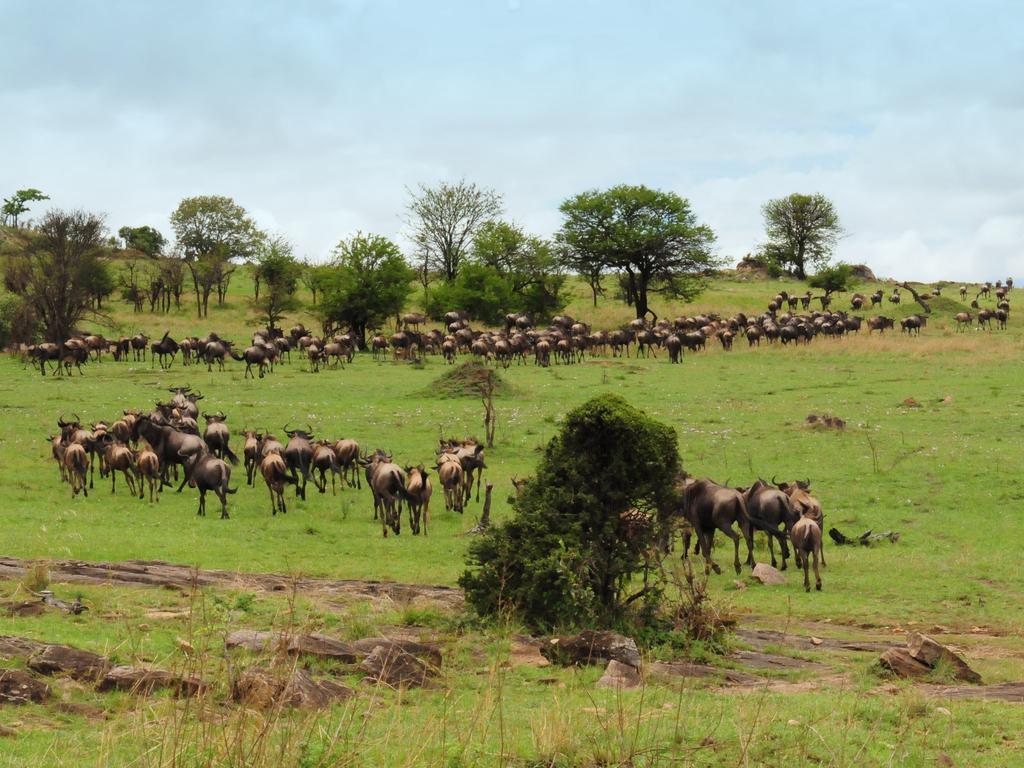Can you describe this image briefly? This image is taken outdoors. At the top of the image there is the sky with clouds. At the bottom of the image there is a ground with grass on it. In the background there are a few trees and plants. In the middle of the image there are a few cattle running on the ground and there are a few rocks. There are a few plants. 